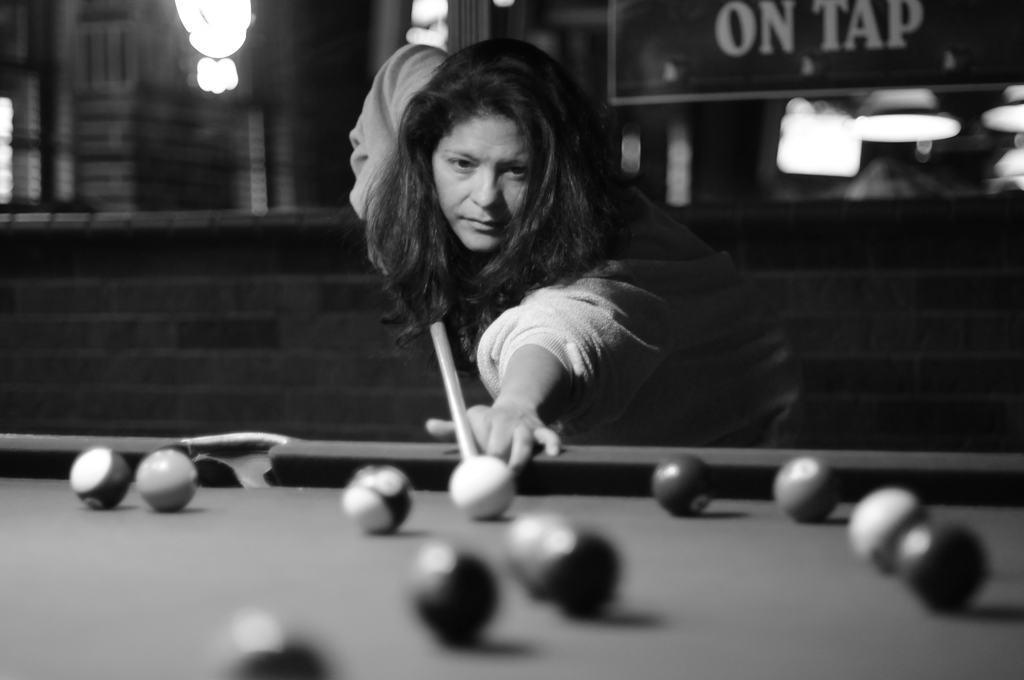How would you summarize this image in a sentence or two? In this image we can see a woman playing billiards. 